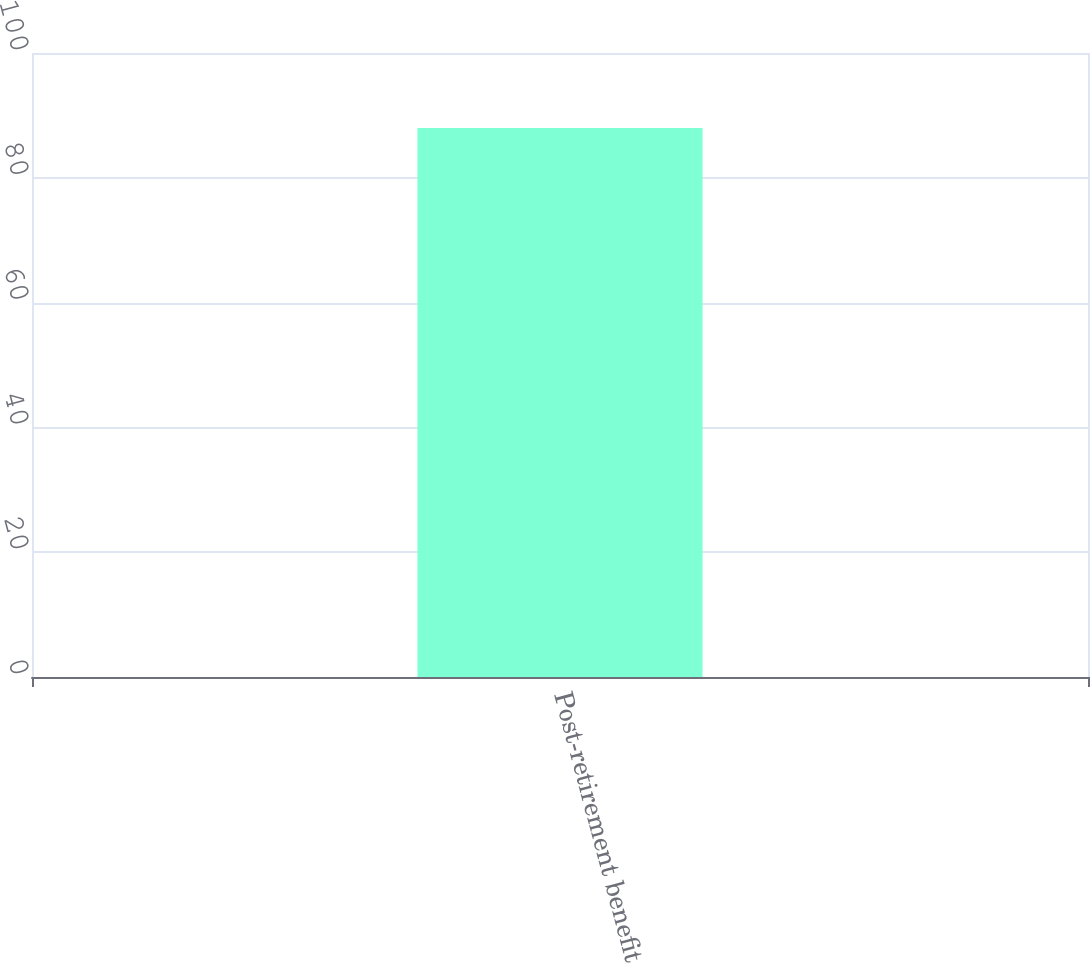Convert chart. <chart><loc_0><loc_0><loc_500><loc_500><bar_chart><fcel>Post-retirement benefit<nl><fcel>88<nl></chart> 